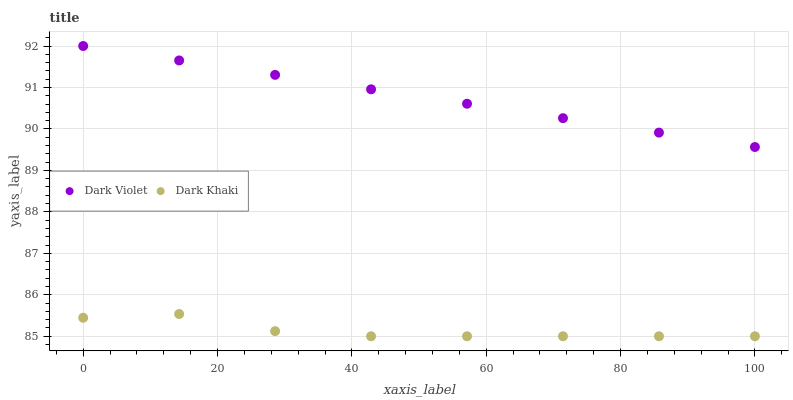Does Dark Khaki have the minimum area under the curve?
Answer yes or no. Yes. Does Dark Violet have the maximum area under the curve?
Answer yes or no. Yes. Does Dark Violet have the minimum area under the curve?
Answer yes or no. No. Is Dark Violet the smoothest?
Answer yes or no. Yes. Is Dark Khaki the roughest?
Answer yes or no. Yes. Is Dark Violet the roughest?
Answer yes or no. No. Does Dark Khaki have the lowest value?
Answer yes or no. Yes. Does Dark Violet have the lowest value?
Answer yes or no. No. Does Dark Violet have the highest value?
Answer yes or no. Yes. Is Dark Khaki less than Dark Violet?
Answer yes or no. Yes. Is Dark Violet greater than Dark Khaki?
Answer yes or no. Yes. Does Dark Khaki intersect Dark Violet?
Answer yes or no. No. 